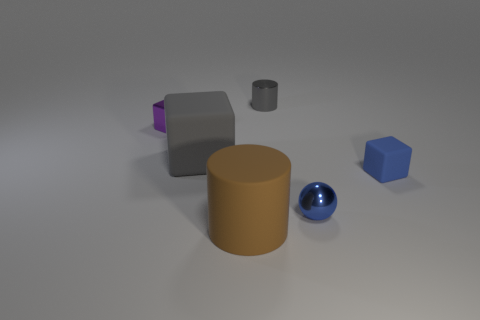What shape is the shiny object that is both on the right side of the gray cube and in front of the gray shiny object?
Keep it short and to the point. Sphere. What number of other tiny shiny cubes have the same color as the shiny cube?
Your response must be concise. 0. There is a gray object that is to the left of the tiny metallic thing behind the purple shiny cube; are there any gray shiny cylinders behind it?
Your answer should be compact. Yes. What size is the metallic thing that is both in front of the gray shiny cylinder and right of the tiny purple block?
Make the answer very short. Small. How many large cylinders have the same material as the blue block?
Offer a terse response. 1. How many cylinders are either yellow matte things or brown objects?
Provide a succinct answer. 1. What is the size of the cylinder that is behind the tiny cube that is to the left of the block in front of the large gray block?
Your answer should be very brief. Small. There is a metallic object that is both to the right of the large rubber block and behind the big block; what is its color?
Ensure brevity in your answer.  Gray. Does the blue shiny object have the same size as the rubber block to the left of the gray metallic object?
Give a very brief answer. No. Are there any other things that are the same shape as the blue shiny thing?
Provide a short and direct response. No. 